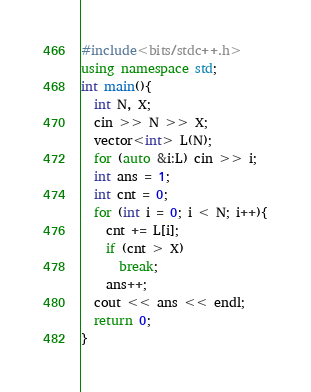<code> <loc_0><loc_0><loc_500><loc_500><_C++_>#include<bits/stdc++.h>
using namespace std;
int main(){
  int N, X;
  cin >> N >> X;
  vector<int> L(N);
  for (auto &i:L) cin >> i;
  int ans = 1;
  int cnt = 0;
  for (int i = 0; i < N; i++){
    cnt += L[i];
    if (cnt > X)
      break;
    ans++;
  cout << ans << endl;
  return 0;
}</code> 